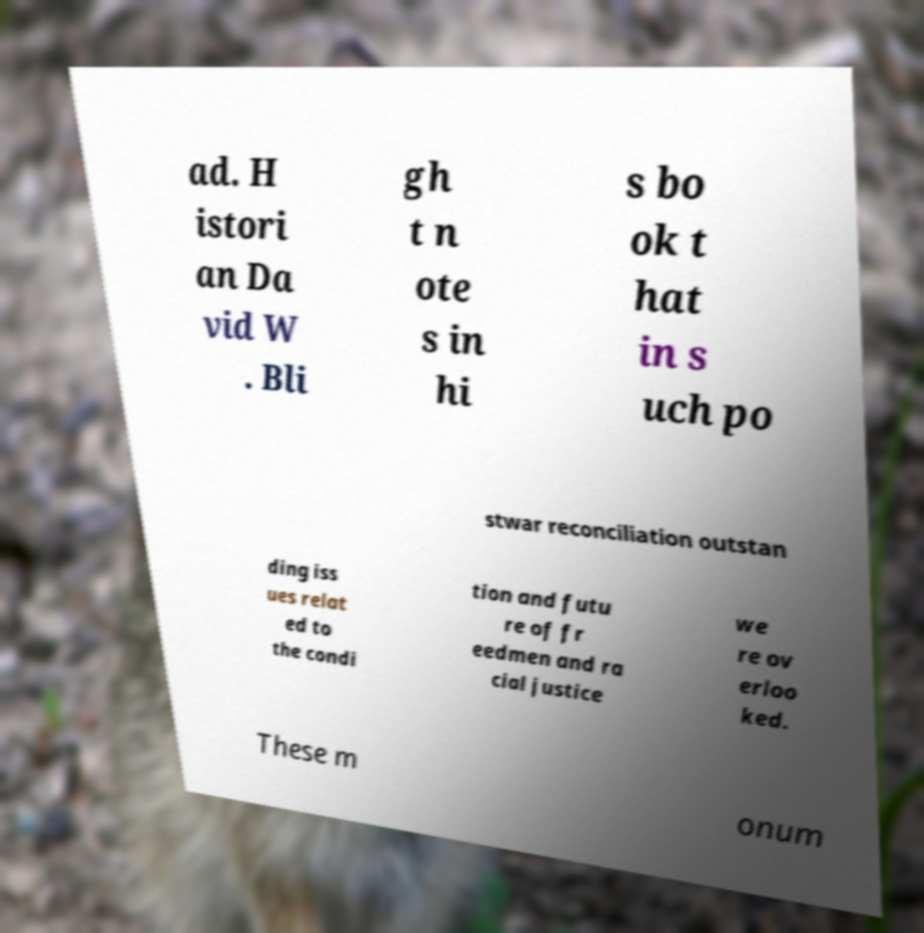Could you assist in decoding the text presented in this image and type it out clearly? ad. H istori an Da vid W . Bli gh t n ote s in hi s bo ok t hat in s uch po stwar reconciliation outstan ding iss ues relat ed to the condi tion and futu re of fr eedmen and ra cial justice we re ov erloo ked. These m onum 